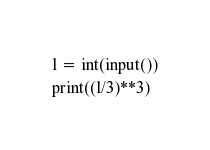<code> <loc_0><loc_0><loc_500><loc_500><_Python_>l = int(input())
print((l/3)**3)</code> 